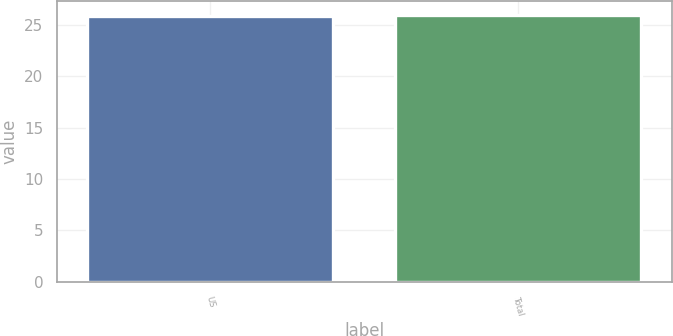Convert chart. <chart><loc_0><loc_0><loc_500><loc_500><bar_chart><fcel>US<fcel>Total<nl><fcel>25.9<fcel>26<nl></chart> 